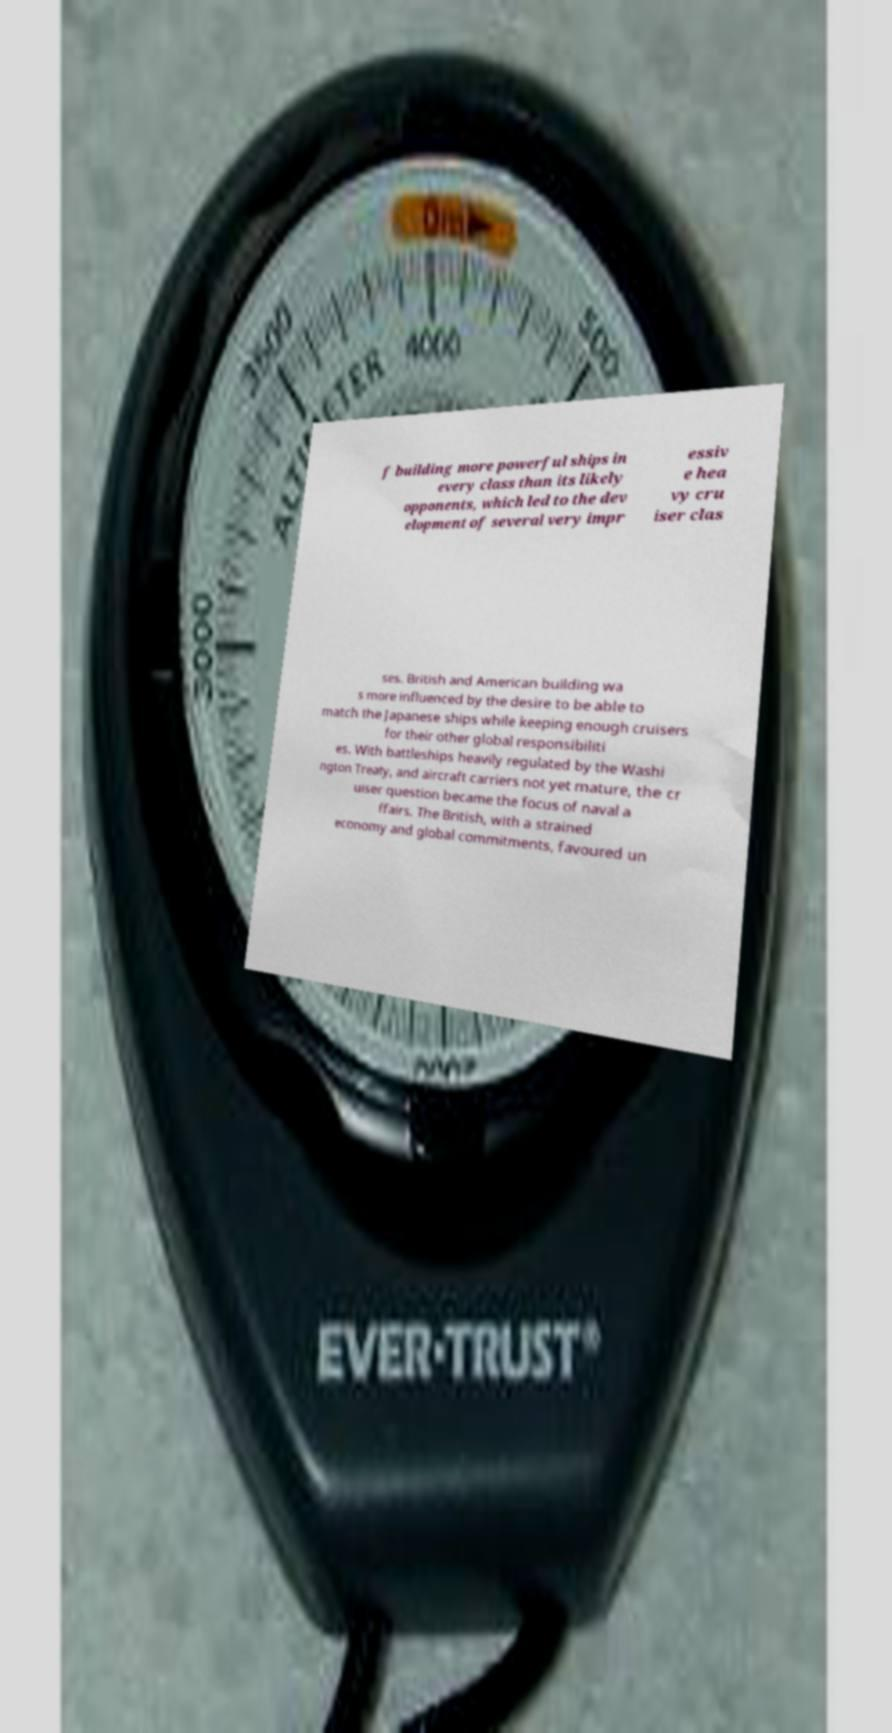Can you read and provide the text displayed in the image?This photo seems to have some interesting text. Can you extract and type it out for me? f building more powerful ships in every class than its likely opponents, which led to the dev elopment of several very impr essiv e hea vy cru iser clas ses. British and American building wa s more influenced by the desire to be able to match the Japanese ships while keeping enough cruisers for their other global responsibiliti es. With battleships heavily regulated by the Washi ngton Treaty, and aircraft carriers not yet mature, the cr uiser question became the focus of naval a ffairs. The British, with a strained economy and global commitments, favoured un 